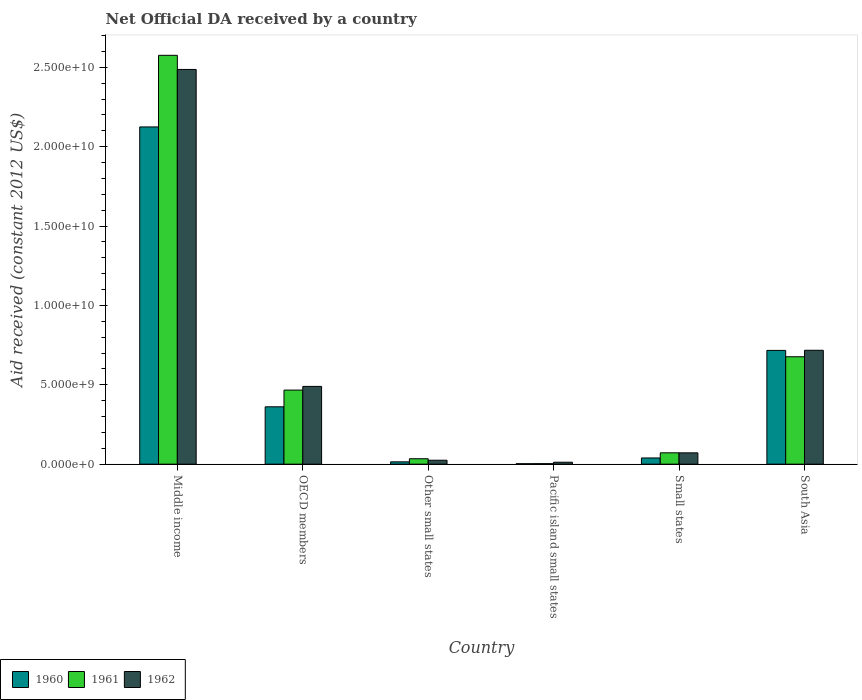How many different coloured bars are there?
Provide a short and direct response. 3. How many groups of bars are there?
Make the answer very short. 6. Are the number of bars per tick equal to the number of legend labels?
Offer a very short reply. Yes. How many bars are there on the 2nd tick from the left?
Ensure brevity in your answer.  3. In how many cases, is the number of bars for a given country not equal to the number of legend labels?
Offer a terse response. 0. What is the net official development assistance aid received in 1962 in Pacific island small states?
Make the answer very short. 1.22e+08. Across all countries, what is the maximum net official development assistance aid received in 1960?
Make the answer very short. 2.12e+1. Across all countries, what is the minimum net official development assistance aid received in 1962?
Your response must be concise. 1.22e+08. In which country was the net official development assistance aid received in 1962 maximum?
Keep it short and to the point. Middle income. In which country was the net official development assistance aid received in 1960 minimum?
Your answer should be very brief. Pacific island small states. What is the total net official development assistance aid received in 1962 in the graph?
Make the answer very short. 3.80e+1. What is the difference between the net official development assistance aid received in 1960 in Other small states and that in Small states?
Offer a terse response. -2.44e+08. What is the difference between the net official development assistance aid received in 1960 in Middle income and the net official development assistance aid received in 1962 in OECD members?
Your response must be concise. 1.63e+1. What is the average net official development assistance aid received in 1960 per country?
Your answer should be compact. 5.43e+09. What is the difference between the net official development assistance aid received of/in 1962 and net official development assistance aid received of/in 1961 in OECD members?
Your answer should be very brief. 2.32e+08. What is the ratio of the net official development assistance aid received in 1962 in Middle income to that in Pacific island small states?
Give a very brief answer. 203.34. What is the difference between the highest and the second highest net official development assistance aid received in 1960?
Your answer should be very brief. 1.76e+1. What is the difference between the highest and the lowest net official development assistance aid received in 1961?
Make the answer very short. 2.57e+1. In how many countries, is the net official development assistance aid received in 1961 greater than the average net official development assistance aid received in 1961 taken over all countries?
Your response must be concise. 2. Is the sum of the net official development assistance aid received in 1961 in OECD members and Small states greater than the maximum net official development assistance aid received in 1960 across all countries?
Provide a succinct answer. No. What does the 1st bar from the left in Pacific island small states represents?
Your response must be concise. 1960. How many bars are there?
Your answer should be compact. 18. Are all the bars in the graph horizontal?
Offer a terse response. No. How many countries are there in the graph?
Offer a very short reply. 6. Does the graph contain any zero values?
Keep it short and to the point. No. Where does the legend appear in the graph?
Your response must be concise. Bottom left. What is the title of the graph?
Your response must be concise. Net Official DA received by a country. Does "1977" appear as one of the legend labels in the graph?
Your answer should be compact. No. What is the label or title of the Y-axis?
Provide a succinct answer. Aid received (constant 2012 US$). What is the Aid received (constant 2012 US$) of 1960 in Middle income?
Provide a succinct answer. 2.12e+1. What is the Aid received (constant 2012 US$) in 1961 in Middle income?
Your answer should be very brief. 2.58e+1. What is the Aid received (constant 2012 US$) of 1962 in Middle income?
Make the answer very short. 2.49e+1. What is the Aid received (constant 2012 US$) of 1960 in OECD members?
Offer a terse response. 3.61e+09. What is the Aid received (constant 2012 US$) in 1961 in OECD members?
Offer a very short reply. 4.67e+09. What is the Aid received (constant 2012 US$) of 1962 in OECD members?
Keep it short and to the point. 4.90e+09. What is the Aid received (constant 2012 US$) of 1960 in Other small states?
Ensure brevity in your answer.  1.46e+08. What is the Aid received (constant 2012 US$) of 1961 in Other small states?
Keep it short and to the point. 3.41e+08. What is the Aid received (constant 2012 US$) in 1962 in Other small states?
Your answer should be compact. 2.48e+08. What is the Aid received (constant 2012 US$) in 1960 in Pacific island small states?
Ensure brevity in your answer.  2.87e+07. What is the Aid received (constant 2012 US$) of 1961 in Pacific island small states?
Your answer should be very brief. 3.25e+07. What is the Aid received (constant 2012 US$) in 1962 in Pacific island small states?
Offer a terse response. 1.22e+08. What is the Aid received (constant 2012 US$) of 1960 in Small states?
Make the answer very short. 3.90e+08. What is the Aid received (constant 2012 US$) of 1961 in Small states?
Provide a succinct answer. 7.15e+08. What is the Aid received (constant 2012 US$) of 1962 in Small states?
Make the answer very short. 7.12e+08. What is the Aid received (constant 2012 US$) of 1960 in South Asia?
Provide a short and direct response. 7.17e+09. What is the Aid received (constant 2012 US$) of 1961 in South Asia?
Your answer should be compact. 6.76e+09. What is the Aid received (constant 2012 US$) in 1962 in South Asia?
Offer a terse response. 7.17e+09. Across all countries, what is the maximum Aid received (constant 2012 US$) in 1960?
Give a very brief answer. 2.12e+1. Across all countries, what is the maximum Aid received (constant 2012 US$) in 1961?
Ensure brevity in your answer.  2.58e+1. Across all countries, what is the maximum Aid received (constant 2012 US$) in 1962?
Offer a terse response. 2.49e+1. Across all countries, what is the minimum Aid received (constant 2012 US$) in 1960?
Keep it short and to the point. 2.87e+07. Across all countries, what is the minimum Aid received (constant 2012 US$) of 1961?
Provide a succinct answer. 3.25e+07. Across all countries, what is the minimum Aid received (constant 2012 US$) of 1962?
Give a very brief answer. 1.22e+08. What is the total Aid received (constant 2012 US$) of 1960 in the graph?
Offer a very short reply. 3.26e+1. What is the total Aid received (constant 2012 US$) of 1961 in the graph?
Offer a very short reply. 3.83e+1. What is the total Aid received (constant 2012 US$) in 1962 in the graph?
Your answer should be very brief. 3.80e+1. What is the difference between the Aid received (constant 2012 US$) in 1960 in Middle income and that in OECD members?
Your response must be concise. 1.76e+1. What is the difference between the Aid received (constant 2012 US$) in 1961 in Middle income and that in OECD members?
Keep it short and to the point. 2.11e+1. What is the difference between the Aid received (constant 2012 US$) in 1962 in Middle income and that in OECD members?
Give a very brief answer. 2.00e+1. What is the difference between the Aid received (constant 2012 US$) in 1960 in Middle income and that in Other small states?
Your response must be concise. 2.11e+1. What is the difference between the Aid received (constant 2012 US$) in 1961 in Middle income and that in Other small states?
Keep it short and to the point. 2.54e+1. What is the difference between the Aid received (constant 2012 US$) in 1962 in Middle income and that in Other small states?
Offer a terse response. 2.46e+1. What is the difference between the Aid received (constant 2012 US$) of 1960 in Middle income and that in Pacific island small states?
Your answer should be very brief. 2.12e+1. What is the difference between the Aid received (constant 2012 US$) of 1961 in Middle income and that in Pacific island small states?
Offer a very short reply. 2.57e+1. What is the difference between the Aid received (constant 2012 US$) of 1962 in Middle income and that in Pacific island small states?
Ensure brevity in your answer.  2.47e+1. What is the difference between the Aid received (constant 2012 US$) of 1960 in Middle income and that in Small states?
Make the answer very short. 2.09e+1. What is the difference between the Aid received (constant 2012 US$) of 1961 in Middle income and that in Small states?
Offer a terse response. 2.50e+1. What is the difference between the Aid received (constant 2012 US$) in 1962 in Middle income and that in Small states?
Make the answer very short. 2.42e+1. What is the difference between the Aid received (constant 2012 US$) of 1960 in Middle income and that in South Asia?
Offer a very short reply. 1.41e+1. What is the difference between the Aid received (constant 2012 US$) in 1961 in Middle income and that in South Asia?
Ensure brevity in your answer.  1.90e+1. What is the difference between the Aid received (constant 2012 US$) in 1962 in Middle income and that in South Asia?
Offer a terse response. 1.77e+1. What is the difference between the Aid received (constant 2012 US$) in 1960 in OECD members and that in Other small states?
Offer a very short reply. 3.47e+09. What is the difference between the Aid received (constant 2012 US$) of 1961 in OECD members and that in Other small states?
Make the answer very short. 4.32e+09. What is the difference between the Aid received (constant 2012 US$) in 1962 in OECD members and that in Other small states?
Give a very brief answer. 4.65e+09. What is the difference between the Aid received (constant 2012 US$) in 1960 in OECD members and that in Pacific island small states?
Keep it short and to the point. 3.58e+09. What is the difference between the Aid received (constant 2012 US$) of 1961 in OECD members and that in Pacific island small states?
Your response must be concise. 4.63e+09. What is the difference between the Aid received (constant 2012 US$) in 1962 in OECD members and that in Pacific island small states?
Offer a terse response. 4.78e+09. What is the difference between the Aid received (constant 2012 US$) in 1960 in OECD members and that in Small states?
Your answer should be compact. 3.22e+09. What is the difference between the Aid received (constant 2012 US$) in 1961 in OECD members and that in Small states?
Offer a very short reply. 3.95e+09. What is the difference between the Aid received (constant 2012 US$) in 1962 in OECD members and that in Small states?
Your response must be concise. 4.19e+09. What is the difference between the Aid received (constant 2012 US$) of 1960 in OECD members and that in South Asia?
Keep it short and to the point. -3.55e+09. What is the difference between the Aid received (constant 2012 US$) in 1961 in OECD members and that in South Asia?
Your response must be concise. -2.10e+09. What is the difference between the Aid received (constant 2012 US$) in 1962 in OECD members and that in South Asia?
Offer a terse response. -2.28e+09. What is the difference between the Aid received (constant 2012 US$) of 1960 in Other small states and that in Pacific island small states?
Ensure brevity in your answer.  1.17e+08. What is the difference between the Aid received (constant 2012 US$) of 1961 in Other small states and that in Pacific island small states?
Keep it short and to the point. 3.09e+08. What is the difference between the Aid received (constant 2012 US$) in 1962 in Other small states and that in Pacific island small states?
Offer a very short reply. 1.26e+08. What is the difference between the Aid received (constant 2012 US$) in 1960 in Other small states and that in Small states?
Your answer should be compact. -2.44e+08. What is the difference between the Aid received (constant 2012 US$) of 1961 in Other small states and that in Small states?
Provide a short and direct response. -3.73e+08. What is the difference between the Aid received (constant 2012 US$) of 1962 in Other small states and that in Small states?
Make the answer very short. -4.64e+08. What is the difference between the Aid received (constant 2012 US$) of 1960 in Other small states and that in South Asia?
Make the answer very short. -7.02e+09. What is the difference between the Aid received (constant 2012 US$) of 1961 in Other small states and that in South Asia?
Provide a short and direct response. -6.42e+09. What is the difference between the Aid received (constant 2012 US$) of 1962 in Other small states and that in South Asia?
Provide a short and direct response. -6.93e+09. What is the difference between the Aid received (constant 2012 US$) in 1960 in Pacific island small states and that in Small states?
Give a very brief answer. -3.62e+08. What is the difference between the Aid received (constant 2012 US$) in 1961 in Pacific island small states and that in Small states?
Give a very brief answer. -6.82e+08. What is the difference between the Aid received (constant 2012 US$) of 1962 in Pacific island small states and that in Small states?
Make the answer very short. -5.90e+08. What is the difference between the Aid received (constant 2012 US$) of 1960 in Pacific island small states and that in South Asia?
Provide a succinct answer. -7.14e+09. What is the difference between the Aid received (constant 2012 US$) of 1961 in Pacific island small states and that in South Asia?
Offer a very short reply. -6.73e+09. What is the difference between the Aid received (constant 2012 US$) in 1962 in Pacific island small states and that in South Asia?
Your answer should be compact. -7.05e+09. What is the difference between the Aid received (constant 2012 US$) in 1960 in Small states and that in South Asia?
Make the answer very short. -6.77e+09. What is the difference between the Aid received (constant 2012 US$) of 1961 in Small states and that in South Asia?
Provide a succinct answer. -6.05e+09. What is the difference between the Aid received (constant 2012 US$) in 1962 in Small states and that in South Asia?
Keep it short and to the point. -6.46e+09. What is the difference between the Aid received (constant 2012 US$) in 1960 in Middle income and the Aid received (constant 2012 US$) in 1961 in OECD members?
Keep it short and to the point. 1.66e+1. What is the difference between the Aid received (constant 2012 US$) in 1960 in Middle income and the Aid received (constant 2012 US$) in 1962 in OECD members?
Offer a terse response. 1.63e+1. What is the difference between the Aid received (constant 2012 US$) of 1961 in Middle income and the Aid received (constant 2012 US$) of 1962 in OECD members?
Your answer should be compact. 2.09e+1. What is the difference between the Aid received (constant 2012 US$) in 1960 in Middle income and the Aid received (constant 2012 US$) in 1961 in Other small states?
Your response must be concise. 2.09e+1. What is the difference between the Aid received (constant 2012 US$) in 1960 in Middle income and the Aid received (constant 2012 US$) in 1962 in Other small states?
Give a very brief answer. 2.10e+1. What is the difference between the Aid received (constant 2012 US$) of 1961 in Middle income and the Aid received (constant 2012 US$) of 1962 in Other small states?
Make the answer very short. 2.55e+1. What is the difference between the Aid received (constant 2012 US$) of 1960 in Middle income and the Aid received (constant 2012 US$) of 1961 in Pacific island small states?
Your answer should be very brief. 2.12e+1. What is the difference between the Aid received (constant 2012 US$) in 1960 in Middle income and the Aid received (constant 2012 US$) in 1962 in Pacific island small states?
Keep it short and to the point. 2.11e+1. What is the difference between the Aid received (constant 2012 US$) of 1961 in Middle income and the Aid received (constant 2012 US$) of 1962 in Pacific island small states?
Offer a very short reply. 2.56e+1. What is the difference between the Aid received (constant 2012 US$) of 1960 in Middle income and the Aid received (constant 2012 US$) of 1961 in Small states?
Provide a succinct answer. 2.05e+1. What is the difference between the Aid received (constant 2012 US$) in 1960 in Middle income and the Aid received (constant 2012 US$) in 1962 in Small states?
Offer a very short reply. 2.05e+1. What is the difference between the Aid received (constant 2012 US$) in 1961 in Middle income and the Aid received (constant 2012 US$) in 1962 in Small states?
Ensure brevity in your answer.  2.50e+1. What is the difference between the Aid received (constant 2012 US$) of 1960 in Middle income and the Aid received (constant 2012 US$) of 1961 in South Asia?
Your answer should be very brief. 1.45e+1. What is the difference between the Aid received (constant 2012 US$) in 1960 in Middle income and the Aid received (constant 2012 US$) in 1962 in South Asia?
Provide a succinct answer. 1.41e+1. What is the difference between the Aid received (constant 2012 US$) of 1961 in Middle income and the Aid received (constant 2012 US$) of 1962 in South Asia?
Offer a very short reply. 1.86e+1. What is the difference between the Aid received (constant 2012 US$) in 1960 in OECD members and the Aid received (constant 2012 US$) in 1961 in Other small states?
Your answer should be very brief. 3.27e+09. What is the difference between the Aid received (constant 2012 US$) in 1960 in OECD members and the Aid received (constant 2012 US$) in 1962 in Other small states?
Keep it short and to the point. 3.36e+09. What is the difference between the Aid received (constant 2012 US$) in 1961 in OECD members and the Aid received (constant 2012 US$) in 1962 in Other small states?
Offer a very short reply. 4.42e+09. What is the difference between the Aid received (constant 2012 US$) in 1960 in OECD members and the Aid received (constant 2012 US$) in 1961 in Pacific island small states?
Provide a succinct answer. 3.58e+09. What is the difference between the Aid received (constant 2012 US$) in 1960 in OECD members and the Aid received (constant 2012 US$) in 1962 in Pacific island small states?
Your answer should be very brief. 3.49e+09. What is the difference between the Aid received (constant 2012 US$) of 1961 in OECD members and the Aid received (constant 2012 US$) of 1962 in Pacific island small states?
Provide a succinct answer. 4.54e+09. What is the difference between the Aid received (constant 2012 US$) of 1960 in OECD members and the Aid received (constant 2012 US$) of 1961 in Small states?
Offer a terse response. 2.90e+09. What is the difference between the Aid received (constant 2012 US$) in 1960 in OECD members and the Aid received (constant 2012 US$) in 1962 in Small states?
Provide a succinct answer. 2.90e+09. What is the difference between the Aid received (constant 2012 US$) in 1961 in OECD members and the Aid received (constant 2012 US$) in 1962 in Small states?
Provide a succinct answer. 3.95e+09. What is the difference between the Aid received (constant 2012 US$) of 1960 in OECD members and the Aid received (constant 2012 US$) of 1961 in South Asia?
Provide a short and direct response. -3.15e+09. What is the difference between the Aid received (constant 2012 US$) of 1960 in OECD members and the Aid received (constant 2012 US$) of 1962 in South Asia?
Make the answer very short. -3.56e+09. What is the difference between the Aid received (constant 2012 US$) of 1961 in OECD members and the Aid received (constant 2012 US$) of 1962 in South Asia?
Keep it short and to the point. -2.51e+09. What is the difference between the Aid received (constant 2012 US$) of 1960 in Other small states and the Aid received (constant 2012 US$) of 1961 in Pacific island small states?
Your answer should be very brief. 1.14e+08. What is the difference between the Aid received (constant 2012 US$) in 1960 in Other small states and the Aid received (constant 2012 US$) in 1962 in Pacific island small states?
Offer a terse response. 2.39e+07. What is the difference between the Aid received (constant 2012 US$) of 1961 in Other small states and the Aid received (constant 2012 US$) of 1962 in Pacific island small states?
Your response must be concise. 2.19e+08. What is the difference between the Aid received (constant 2012 US$) of 1960 in Other small states and the Aid received (constant 2012 US$) of 1961 in Small states?
Offer a terse response. -5.69e+08. What is the difference between the Aid received (constant 2012 US$) in 1960 in Other small states and the Aid received (constant 2012 US$) in 1962 in Small states?
Give a very brief answer. -5.66e+08. What is the difference between the Aid received (constant 2012 US$) of 1961 in Other small states and the Aid received (constant 2012 US$) of 1962 in Small states?
Your answer should be very brief. -3.71e+08. What is the difference between the Aid received (constant 2012 US$) in 1960 in Other small states and the Aid received (constant 2012 US$) in 1961 in South Asia?
Offer a very short reply. -6.62e+09. What is the difference between the Aid received (constant 2012 US$) of 1960 in Other small states and the Aid received (constant 2012 US$) of 1962 in South Asia?
Your answer should be compact. -7.03e+09. What is the difference between the Aid received (constant 2012 US$) of 1961 in Other small states and the Aid received (constant 2012 US$) of 1962 in South Asia?
Offer a very short reply. -6.83e+09. What is the difference between the Aid received (constant 2012 US$) in 1960 in Pacific island small states and the Aid received (constant 2012 US$) in 1961 in Small states?
Provide a short and direct response. -6.86e+08. What is the difference between the Aid received (constant 2012 US$) in 1960 in Pacific island small states and the Aid received (constant 2012 US$) in 1962 in Small states?
Make the answer very short. -6.83e+08. What is the difference between the Aid received (constant 2012 US$) of 1961 in Pacific island small states and the Aid received (constant 2012 US$) of 1962 in Small states?
Your answer should be very brief. -6.80e+08. What is the difference between the Aid received (constant 2012 US$) in 1960 in Pacific island small states and the Aid received (constant 2012 US$) in 1961 in South Asia?
Your answer should be very brief. -6.74e+09. What is the difference between the Aid received (constant 2012 US$) in 1960 in Pacific island small states and the Aid received (constant 2012 US$) in 1962 in South Asia?
Make the answer very short. -7.14e+09. What is the difference between the Aid received (constant 2012 US$) in 1961 in Pacific island small states and the Aid received (constant 2012 US$) in 1962 in South Asia?
Provide a succinct answer. -7.14e+09. What is the difference between the Aid received (constant 2012 US$) in 1960 in Small states and the Aid received (constant 2012 US$) in 1961 in South Asia?
Offer a terse response. -6.37e+09. What is the difference between the Aid received (constant 2012 US$) in 1960 in Small states and the Aid received (constant 2012 US$) in 1962 in South Asia?
Give a very brief answer. -6.78e+09. What is the difference between the Aid received (constant 2012 US$) of 1961 in Small states and the Aid received (constant 2012 US$) of 1962 in South Asia?
Ensure brevity in your answer.  -6.46e+09. What is the average Aid received (constant 2012 US$) in 1960 per country?
Make the answer very short. 5.43e+09. What is the average Aid received (constant 2012 US$) in 1961 per country?
Provide a short and direct response. 6.38e+09. What is the average Aid received (constant 2012 US$) in 1962 per country?
Make the answer very short. 6.34e+09. What is the difference between the Aid received (constant 2012 US$) in 1960 and Aid received (constant 2012 US$) in 1961 in Middle income?
Offer a terse response. -4.51e+09. What is the difference between the Aid received (constant 2012 US$) of 1960 and Aid received (constant 2012 US$) of 1962 in Middle income?
Provide a succinct answer. -3.62e+09. What is the difference between the Aid received (constant 2012 US$) of 1961 and Aid received (constant 2012 US$) of 1962 in Middle income?
Make the answer very short. 8.89e+08. What is the difference between the Aid received (constant 2012 US$) in 1960 and Aid received (constant 2012 US$) in 1961 in OECD members?
Your response must be concise. -1.05e+09. What is the difference between the Aid received (constant 2012 US$) in 1960 and Aid received (constant 2012 US$) in 1962 in OECD members?
Your answer should be compact. -1.28e+09. What is the difference between the Aid received (constant 2012 US$) of 1961 and Aid received (constant 2012 US$) of 1962 in OECD members?
Ensure brevity in your answer.  -2.32e+08. What is the difference between the Aid received (constant 2012 US$) of 1960 and Aid received (constant 2012 US$) of 1961 in Other small states?
Provide a short and direct response. -1.95e+08. What is the difference between the Aid received (constant 2012 US$) of 1960 and Aid received (constant 2012 US$) of 1962 in Other small states?
Your response must be concise. -1.02e+08. What is the difference between the Aid received (constant 2012 US$) in 1961 and Aid received (constant 2012 US$) in 1962 in Other small states?
Ensure brevity in your answer.  9.32e+07. What is the difference between the Aid received (constant 2012 US$) of 1960 and Aid received (constant 2012 US$) of 1961 in Pacific island small states?
Make the answer very short. -3.76e+06. What is the difference between the Aid received (constant 2012 US$) in 1960 and Aid received (constant 2012 US$) in 1962 in Pacific island small states?
Offer a very short reply. -9.36e+07. What is the difference between the Aid received (constant 2012 US$) of 1961 and Aid received (constant 2012 US$) of 1962 in Pacific island small states?
Keep it short and to the point. -8.98e+07. What is the difference between the Aid received (constant 2012 US$) in 1960 and Aid received (constant 2012 US$) in 1961 in Small states?
Offer a very short reply. -3.24e+08. What is the difference between the Aid received (constant 2012 US$) in 1960 and Aid received (constant 2012 US$) in 1962 in Small states?
Your answer should be compact. -3.22e+08. What is the difference between the Aid received (constant 2012 US$) of 1961 and Aid received (constant 2012 US$) of 1962 in Small states?
Your response must be concise. 2.71e+06. What is the difference between the Aid received (constant 2012 US$) of 1960 and Aid received (constant 2012 US$) of 1961 in South Asia?
Offer a terse response. 4.00e+08. What is the difference between the Aid received (constant 2012 US$) in 1960 and Aid received (constant 2012 US$) in 1962 in South Asia?
Your answer should be very brief. -8.03e+06. What is the difference between the Aid received (constant 2012 US$) in 1961 and Aid received (constant 2012 US$) in 1962 in South Asia?
Provide a succinct answer. -4.08e+08. What is the ratio of the Aid received (constant 2012 US$) in 1960 in Middle income to that in OECD members?
Provide a succinct answer. 5.88. What is the ratio of the Aid received (constant 2012 US$) of 1961 in Middle income to that in OECD members?
Your answer should be very brief. 5.52. What is the ratio of the Aid received (constant 2012 US$) of 1962 in Middle income to that in OECD members?
Offer a very short reply. 5.08. What is the ratio of the Aid received (constant 2012 US$) in 1960 in Middle income to that in Other small states?
Your response must be concise. 145.35. What is the ratio of the Aid received (constant 2012 US$) in 1961 in Middle income to that in Other small states?
Provide a short and direct response. 75.42. What is the ratio of the Aid received (constant 2012 US$) in 1962 in Middle income to that in Other small states?
Offer a very short reply. 100.17. What is the ratio of the Aid received (constant 2012 US$) of 1960 in Middle income to that in Pacific island small states?
Your response must be concise. 739.85. What is the ratio of the Aid received (constant 2012 US$) in 1961 in Middle income to that in Pacific island small states?
Your answer should be compact. 793.09. What is the ratio of the Aid received (constant 2012 US$) of 1962 in Middle income to that in Pacific island small states?
Keep it short and to the point. 203.34. What is the ratio of the Aid received (constant 2012 US$) of 1960 in Middle income to that in Small states?
Your answer should be compact. 54.42. What is the ratio of the Aid received (constant 2012 US$) of 1961 in Middle income to that in Small states?
Make the answer very short. 36.03. What is the ratio of the Aid received (constant 2012 US$) in 1962 in Middle income to that in Small states?
Provide a succinct answer. 34.92. What is the ratio of the Aid received (constant 2012 US$) in 1960 in Middle income to that in South Asia?
Give a very brief answer. 2.96. What is the ratio of the Aid received (constant 2012 US$) in 1961 in Middle income to that in South Asia?
Ensure brevity in your answer.  3.81. What is the ratio of the Aid received (constant 2012 US$) of 1962 in Middle income to that in South Asia?
Keep it short and to the point. 3.47. What is the ratio of the Aid received (constant 2012 US$) in 1960 in OECD members to that in Other small states?
Your answer should be compact. 24.72. What is the ratio of the Aid received (constant 2012 US$) of 1961 in OECD members to that in Other small states?
Make the answer very short. 13.66. What is the ratio of the Aid received (constant 2012 US$) of 1962 in OECD members to that in Other small states?
Keep it short and to the point. 19.73. What is the ratio of the Aid received (constant 2012 US$) of 1960 in OECD members to that in Pacific island small states?
Ensure brevity in your answer.  125.84. What is the ratio of the Aid received (constant 2012 US$) in 1961 in OECD members to that in Pacific island small states?
Offer a terse response. 143.69. What is the ratio of the Aid received (constant 2012 US$) of 1962 in OECD members to that in Pacific island small states?
Offer a very short reply. 40.06. What is the ratio of the Aid received (constant 2012 US$) in 1960 in OECD members to that in Small states?
Your answer should be compact. 9.26. What is the ratio of the Aid received (constant 2012 US$) of 1961 in OECD members to that in Small states?
Your answer should be very brief. 6.53. What is the ratio of the Aid received (constant 2012 US$) of 1962 in OECD members to that in Small states?
Keep it short and to the point. 6.88. What is the ratio of the Aid received (constant 2012 US$) of 1960 in OECD members to that in South Asia?
Ensure brevity in your answer.  0.5. What is the ratio of the Aid received (constant 2012 US$) of 1961 in OECD members to that in South Asia?
Your answer should be compact. 0.69. What is the ratio of the Aid received (constant 2012 US$) in 1962 in OECD members to that in South Asia?
Your answer should be very brief. 0.68. What is the ratio of the Aid received (constant 2012 US$) in 1960 in Other small states to that in Pacific island small states?
Give a very brief answer. 5.09. What is the ratio of the Aid received (constant 2012 US$) in 1961 in Other small states to that in Pacific island small states?
Offer a very short reply. 10.52. What is the ratio of the Aid received (constant 2012 US$) in 1962 in Other small states to that in Pacific island small states?
Provide a short and direct response. 2.03. What is the ratio of the Aid received (constant 2012 US$) in 1960 in Other small states to that in Small states?
Your answer should be compact. 0.37. What is the ratio of the Aid received (constant 2012 US$) in 1961 in Other small states to that in Small states?
Give a very brief answer. 0.48. What is the ratio of the Aid received (constant 2012 US$) in 1962 in Other small states to that in Small states?
Ensure brevity in your answer.  0.35. What is the ratio of the Aid received (constant 2012 US$) of 1960 in Other small states to that in South Asia?
Offer a very short reply. 0.02. What is the ratio of the Aid received (constant 2012 US$) in 1961 in Other small states to that in South Asia?
Keep it short and to the point. 0.05. What is the ratio of the Aid received (constant 2012 US$) of 1962 in Other small states to that in South Asia?
Provide a short and direct response. 0.03. What is the ratio of the Aid received (constant 2012 US$) of 1960 in Pacific island small states to that in Small states?
Provide a succinct answer. 0.07. What is the ratio of the Aid received (constant 2012 US$) of 1961 in Pacific island small states to that in Small states?
Provide a short and direct response. 0.05. What is the ratio of the Aid received (constant 2012 US$) of 1962 in Pacific island small states to that in Small states?
Offer a terse response. 0.17. What is the ratio of the Aid received (constant 2012 US$) of 1960 in Pacific island small states to that in South Asia?
Make the answer very short. 0. What is the ratio of the Aid received (constant 2012 US$) of 1961 in Pacific island small states to that in South Asia?
Keep it short and to the point. 0. What is the ratio of the Aid received (constant 2012 US$) in 1962 in Pacific island small states to that in South Asia?
Give a very brief answer. 0.02. What is the ratio of the Aid received (constant 2012 US$) of 1960 in Small states to that in South Asia?
Keep it short and to the point. 0.05. What is the ratio of the Aid received (constant 2012 US$) in 1961 in Small states to that in South Asia?
Ensure brevity in your answer.  0.11. What is the ratio of the Aid received (constant 2012 US$) in 1962 in Small states to that in South Asia?
Offer a terse response. 0.1. What is the difference between the highest and the second highest Aid received (constant 2012 US$) of 1960?
Your answer should be very brief. 1.41e+1. What is the difference between the highest and the second highest Aid received (constant 2012 US$) in 1961?
Your answer should be very brief. 1.90e+1. What is the difference between the highest and the second highest Aid received (constant 2012 US$) of 1962?
Provide a short and direct response. 1.77e+1. What is the difference between the highest and the lowest Aid received (constant 2012 US$) in 1960?
Your response must be concise. 2.12e+1. What is the difference between the highest and the lowest Aid received (constant 2012 US$) of 1961?
Offer a terse response. 2.57e+1. What is the difference between the highest and the lowest Aid received (constant 2012 US$) in 1962?
Offer a terse response. 2.47e+1. 